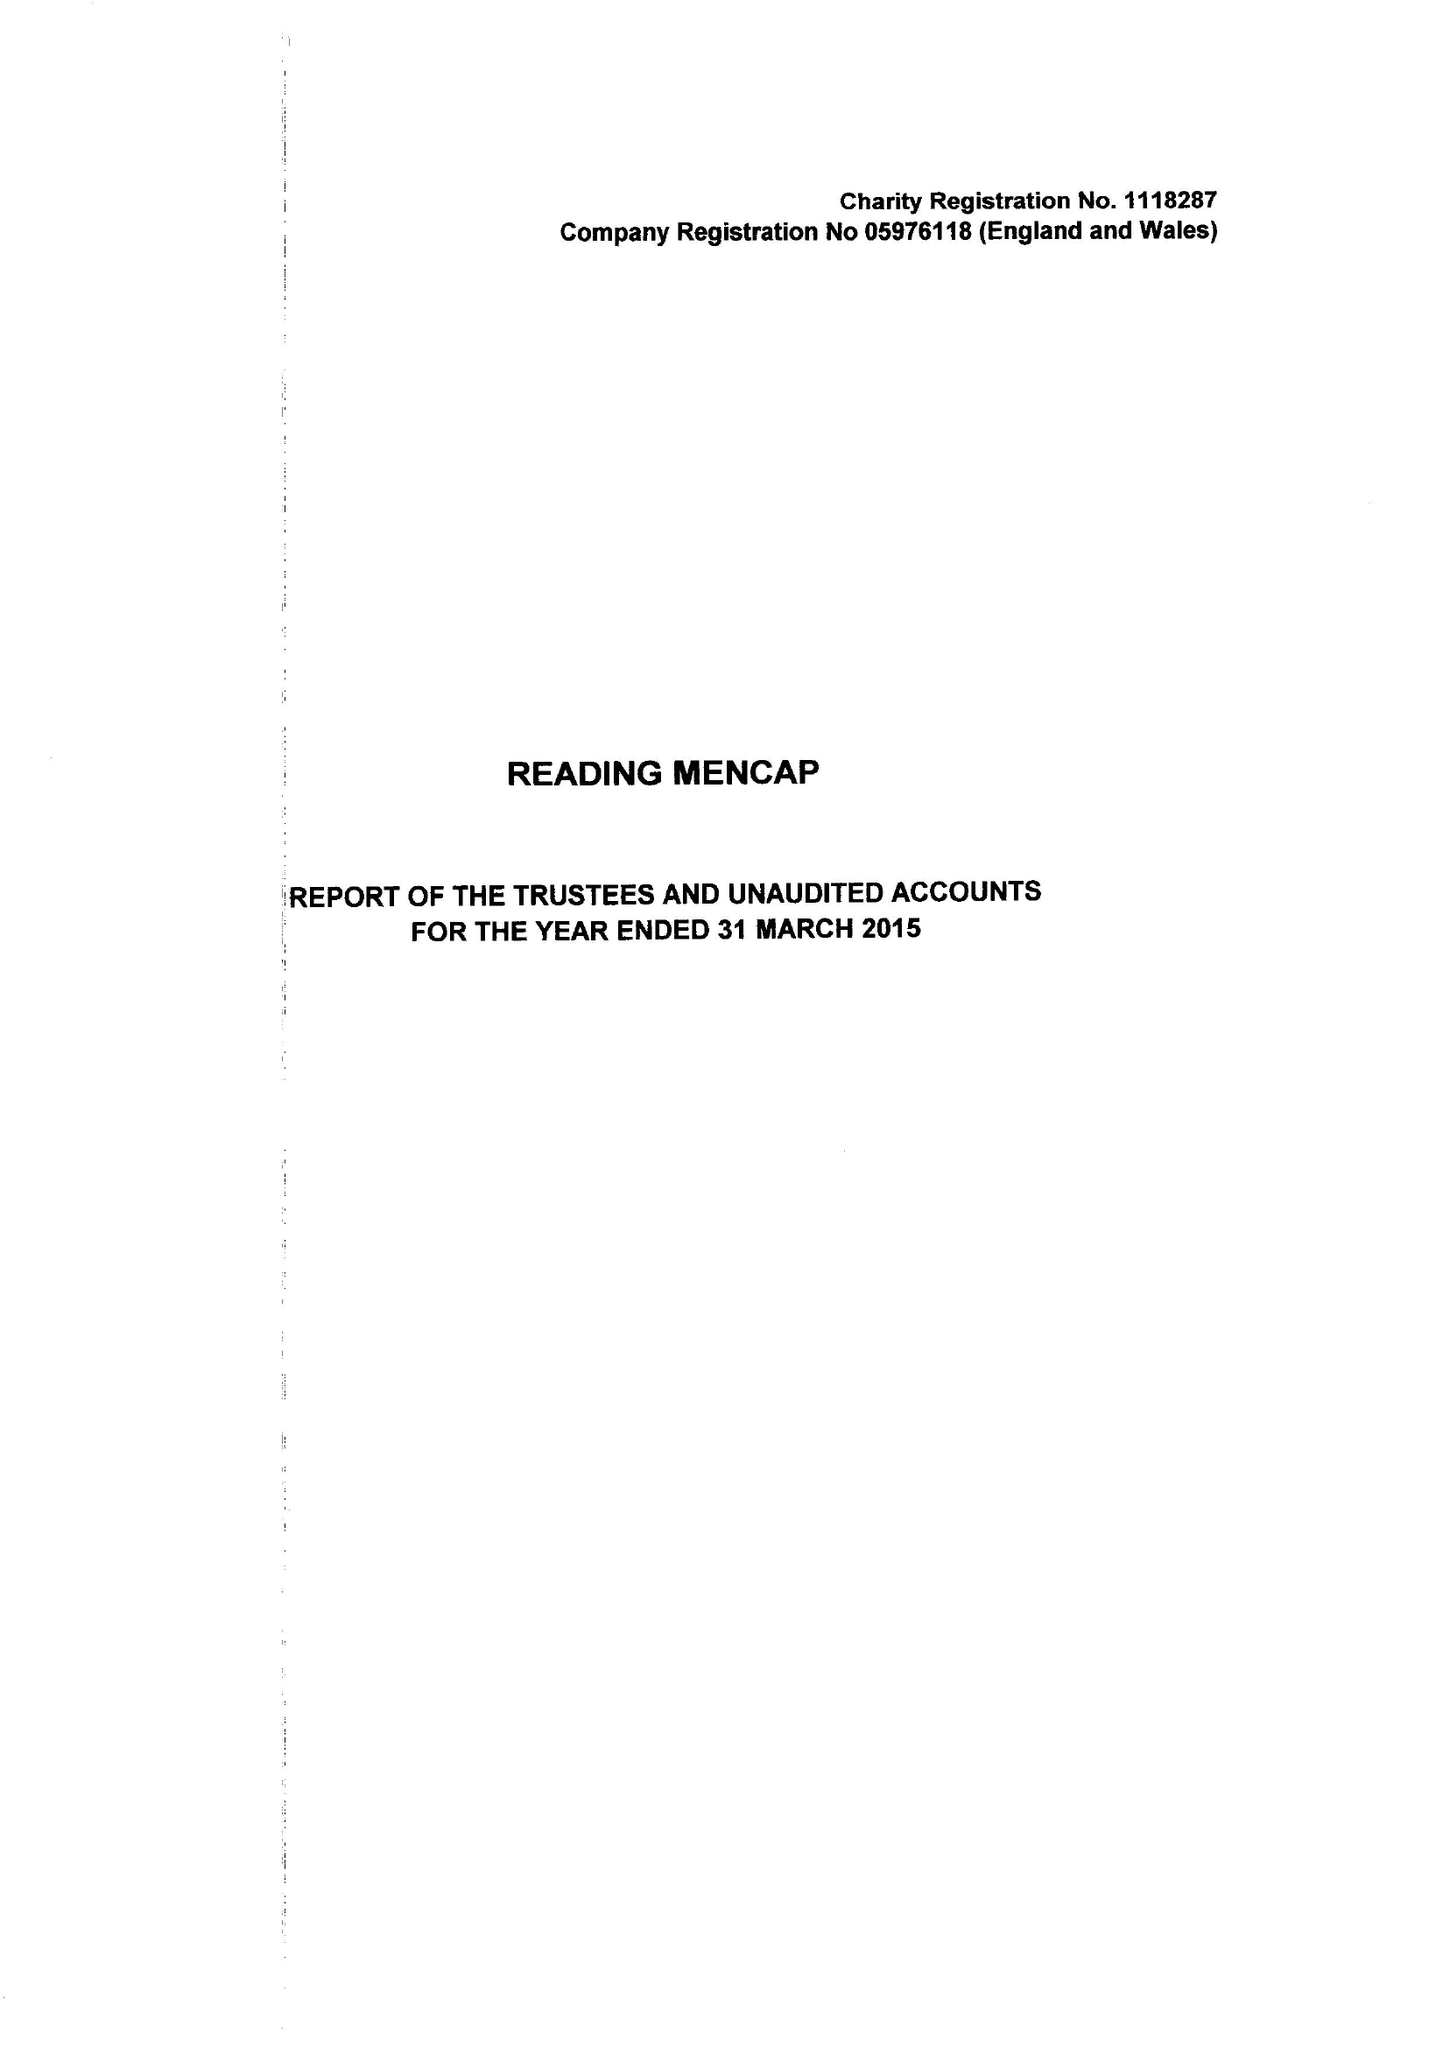What is the value for the charity_name?
Answer the question using a single word or phrase. Reading Mencap 